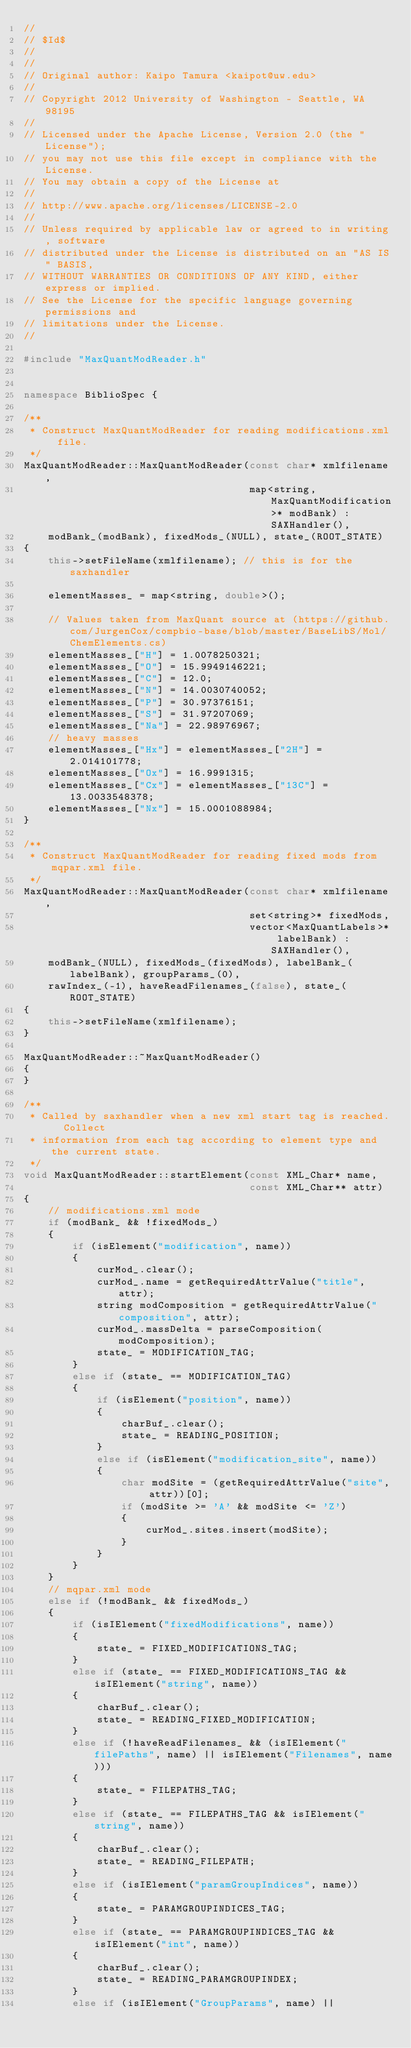<code> <loc_0><loc_0><loc_500><loc_500><_C++_>//
// $Id$
//
//
// Original author: Kaipo Tamura <kaipot@uw.edu>
//
// Copyright 2012 University of Washington - Seattle, WA 98195
//
// Licensed under the Apache License, Version 2.0 (the "License"); 
// you may not use this file except in compliance with the License. 
// You may obtain a copy of the License at 
//
// http://www.apache.org/licenses/LICENSE-2.0
//
// Unless required by applicable law or agreed to in writing, software 
// distributed under the License is distributed on an "AS IS" BASIS, 
// WITHOUT WARRANTIES OR CONDITIONS OF ANY KIND, either express or implied. 
// See the License for the specific language governing permissions and 
// limitations under the License.
//

#include "MaxQuantModReader.h"


namespace BiblioSpec {

/**
 * Construct MaxQuantModReader for reading modifications.xml file.
 */
MaxQuantModReader::MaxQuantModReader(const char* xmlfilename,
                                     map<string, MaxQuantModification>* modBank) : SAXHandler(),
    modBank_(modBank), fixedMods_(NULL), state_(ROOT_STATE)
{
    this->setFileName(xmlfilename); // this is for the saxhandler
   
    elementMasses_ = map<string, double>();

    // Values taken from MaxQuant source at (https://github.com/JurgenCox/compbio-base/blob/master/BaseLibS/Mol/ChemElements.cs)
    elementMasses_["H"] = 1.0078250321;
    elementMasses_["O"] = 15.9949146221;
    elementMasses_["C"] = 12.0;
    elementMasses_["N"] = 14.0030740052;
    elementMasses_["P"] = 30.97376151;
    elementMasses_["S"] = 31.97207069;
    elementMasses_["Na"] = 22.98976967;
    // heavy masses
    elementMasses_["Hx"] = elementMasses_["2H"] = 2.014101778;
    elementMasses_["Ox"] = 16.9991315;
    elementMasses_["Cx"] = elementMasses_["13C"] = 13.0033548378;
    elementMasses_["Nx"] = 15.0001088984;
}

/**
 * Construct MaxQuantModReader for reading fixed mods from mqpar.xml file.
 */
MaxQuantModReader::MaxQuantModReader(const char* xmlfilename,
                                     set<string>* fixedMods,
                                     vector<MaxQuantLabels>* labelBank) : SAXHandler(),
    modBank_(NULL), fixedMods_(fixedMods), labelBank_(labelBank), groupParams_(0),
    rawIndex_(-1), haveReadFilenames_(false), state_(ROOT_STATE)
{
    this->setFileName(xmlfilename);
}

MaxQuantModReader::~MaxQuantModReader()
{
}

/**
 * Called by saxhandler when a new xml start tag is reached.  Collect
 * information from each tag according to element type and the current state.
 */
void MaxQuantModReader::startElement(const XML_Char* name, 
                                     const XML_Char** attr)
{
    // modifications.xml mode
    if (modBank_ && !fixedMods_)
    {
        if (isElement("modification", name))
        {
            curMod_.clear();
            curMod_.name = getRequiredAttrValue("title", attr);
            string modComposition = getRequiredAttrValue("composition", attr);
            curMod_.massDelta = parseComposition(modComposition);
            state_ = MODIFICATION_TAG;
        }
        else if (state_ == MODIFICATION_TAG)
        {
            if (isElement("position", name))
            {
                charBuf_.clear();
                state_ = READING_POSITION;
            }
            else if (isElement("modification_site", name))
            {
                char modSite = (getRequiredAttrValue("site", attr))[0];
                if (modSite >= 'A' && modSite <= 'Z')
                {
                    curMod_.sites.insert(modSite);
                }
            }
        }
    }
    // mqpar.xml mode
    else if (!modBank_ && fixedMods_)
    {
        if (isIElement("fixedModifications", name))
        {
            state_ = FIXED_MODIFICATIONS_TAG;
        }
        else if (state_ == FIXED_MODIFICATIONS_TAG && isIElement("string", name))
        {
            charBuf_.clear();
            state_ = READING_FIXED_MODIFICATION;
        }
        else if (!haveReadFilenames_ && (isIElement("filePaths", name) || isIElement("Filenames", name)))
        {
            state_ = FILEPATHS_TAG;
        }
        else if (state_ == FILEPATHS_TAG && isIElement("string", name))
        {
            charBuf_.clear();
            state_ = READING_FILEPATH;
        }
        else if (isIElement("paramGroupIndices", name))
        {
            state_ = PARAMGROUPINDICES_TAG;
        }
        else if (state_ == PARAMGROUPINDICES_TAG && isIElement("int", name))
        {
            charBuf_.clear();
            state_ = READING_PARAMGROUPINDEX;
        }
        else if (isIElement("GroupParams", name) ||</code> 